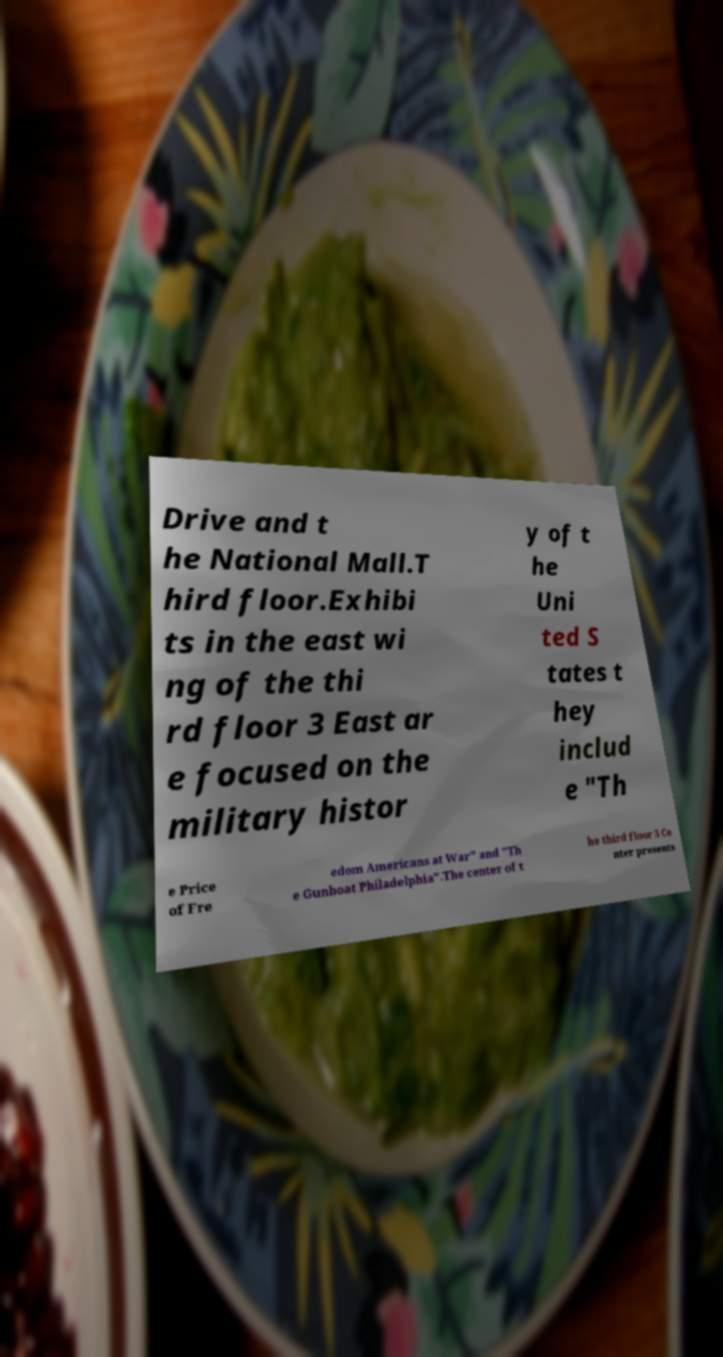There's text embedded in this image that I need extracted. Can you transcribe it verbatim? Drive and t he National Mall.T hird floor.Exhibi ts in the east wi ng of the thi rd floor 3 East ar e focused on the military histor y of t he Uni ted S tates t hey includ e "Th e Price of Fre edom Americans at War" and "Th e Gunboat Philadelphia".The center of t he third floor 3 Ce nter presents 